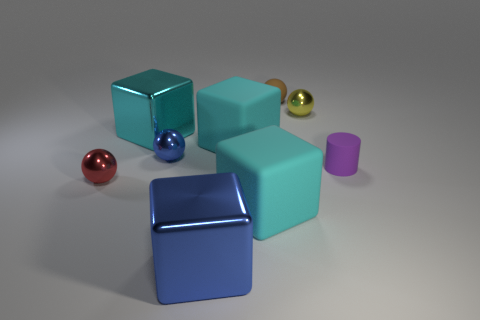There is a large rubber cube in front of the tiny purple cylinder; is its color the same as the shiny cube behind the blue block? The large rubber cube in question appears to be of a teal or cyan color, differing from the shiny cube behind the blue block, which has a deeper, metallic blue hue. Even though there is a similarity in that both cubes have shades of blue, their exact colors are not the same. 